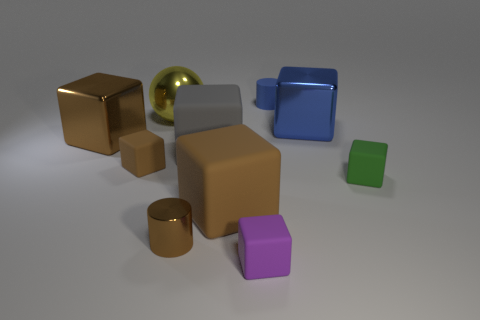There is a purple rubber thing; does it have the same shape as the large matte thing in front of the green rubber block?
Your answer should be compact. Yes. How many things are small matte cubes that are left of the big blue object or cubes that are left of the green rubber cube?
Provide a succinct answer. 6. Is the number of big metallic blocks to the left of the large brown metal thing less than the number of tiny green cubes?
Your answer should be compact. Yes. Do the small brown cylinder and the large thing that is on the right side of the tiny matte cylinder have the same material?
Provide a short and direct response. Yes. What is the blue cylinder made of?
Offer a terse response. Rubber. What material is the large block in front of the small cube right of the object that is in front of the tiny brown cylinder?
Your answer should be compact. Rubber. Is the color of the big ball the same as the tiny matte thing behind the metallic ball?
Provide a succinct answer. No. Are there any other things that have the same shape as the big brown matte thing?
Keep it short and to the point. Yes. The shiny block on the left side of the brown matte block to the left of the large yellow thing is what color?
Provide a short and direct response. Brown. How many small green things are there?
Make the answer very short. 1. 